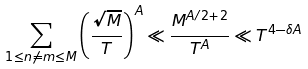<formula> <loc_0><loc_0><loc_500><loc_500>\sum _ { 1 \leq n \neq m \leq M } \left ( \frac { \sqrt { M } } { T } \right ) ^ { A } \ll \frac { M ^ { A / 2 + 2 } } { T ^ { A } } \ll T ^ { 4 - \delta A }</formula> 